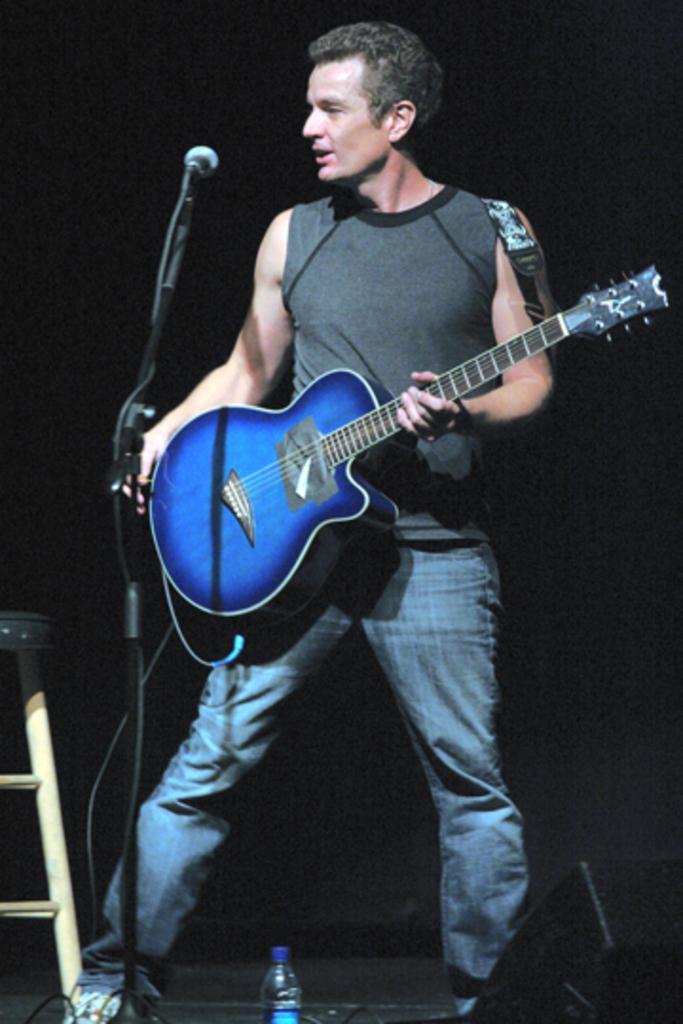Can you describe this image briefly? In this image we can see there is a person holding a guitar. There is a microphone, bottle and stool. In the background it is dark. 